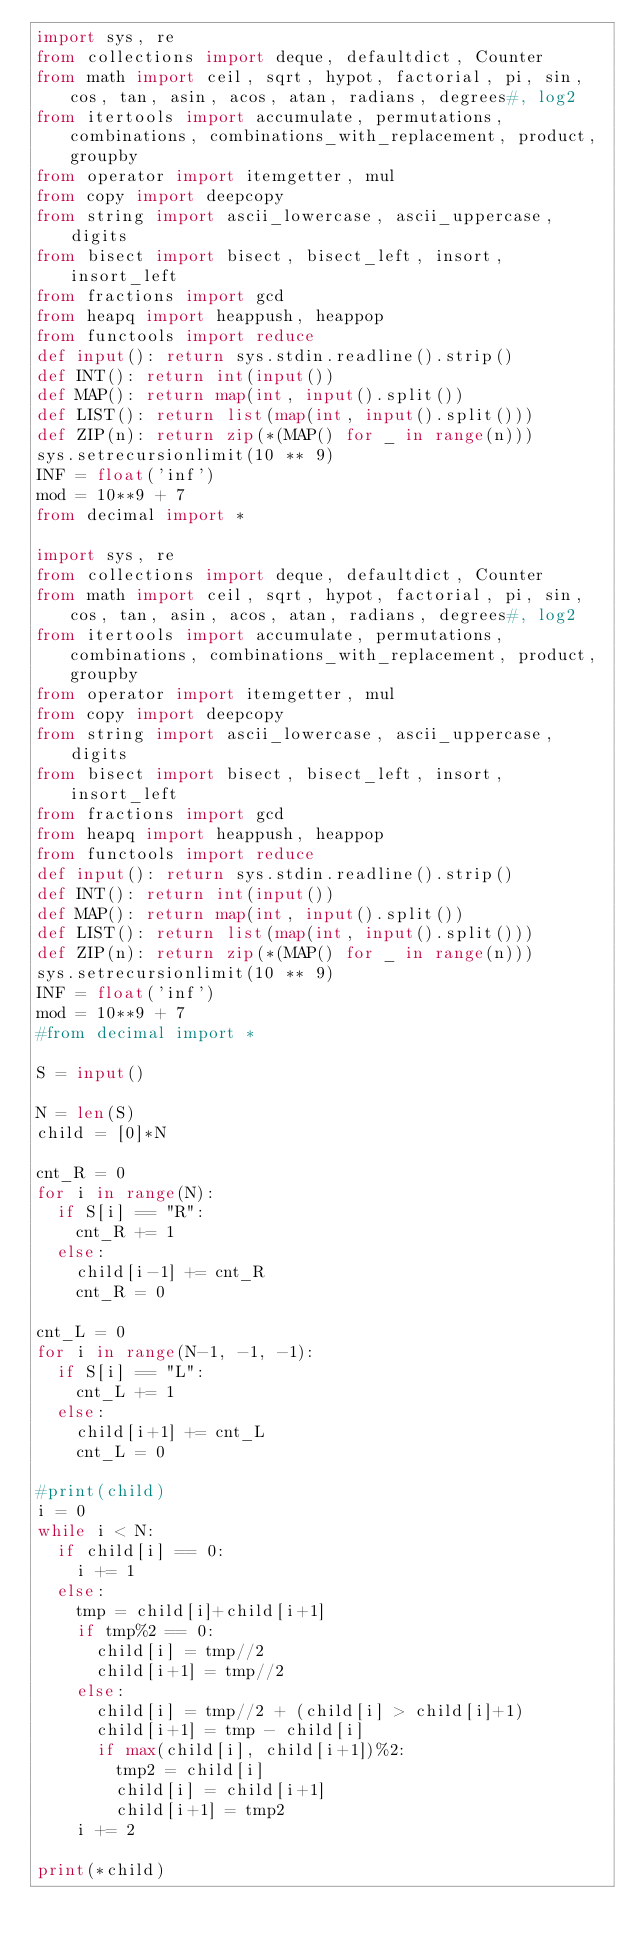<code> <loc_0><loc_0><loc_500><loc_500><_Python_>import sys, re
from collections import deque, defaultdict, Counter
from math import ceil, sqrt, hypot, factorial, pi, sin, cos, tan, asin, acos, atan, radians, degrees#, log2
from itertools import accumulate, permutations, combinations, combinations_with_replacement, product, groupby
from operator import itemgetter, mul
from copy import deepcopy
from string import ascii_lowercase, ascii_uppercase, digits
from bisect import bisect, bisect_left, insort, insort_left
from fractions import gcd
from heapq import heappush, heappop
from functools import reduce
def input(): return sys.stdin.readline().strip()
def INT(): return int(input())
def MAP(): return map(int, input().split())
def LIST(): return list(map(int, input().split()))
def ZIP(n): return zip(*(MAP() for _ in range(n)))
sys.setrecursionlimit(10 ** 9)
INF = float('inf')
mod = 10**9 + 7
from decimal import *

import sys, re
from collections import deque, defaultdict, Counter
from math import ceil, sqrt, hypot, factorial, pi, sin, cos, tan, asin, acos, atan, radians, degrees#, log2
from itertools import accumulate, permutations, combinations, combinations_with_replacement, product, groupby
from operator import itemgetter, mul
from copy import deepcopy
from string import ascii_lowercase, ascii_uppercase, digits
from bisect import bisect, bisect_left, insort, insort_left
from fractions import gcd
from heapq import heappush, heappop
from functools import reduce
def input(): return sys.stdin.readline().strip()
def INT(): return int(input())
def MAP(): return map(int, input().split())
def LIST(): return list(map(int, input().split()))
def ZIP(n): return zip(*(MAP() for _ in range(n)))
sys.setrecursionlimit(10 ** 9)
INF = float('inf')
mod = 10**9 + 7
#from decimal import *
 
S = input()
 
N = len(S)
child = [0]*N
 
cnt_R = 0
for i in range(N):
	if S[i] == "R":
		cnt_R += 1
	else:
		child[i-1] += cnt_R
		cnt_R = 0

cnt_L = 0
for i in range(N-1, -1, -1):
	if S[i] == "L":
		cnt_L += 1
	else:
		child[i+1] += cnt_L
		cnt_L = 0
 
#print(child)
i = 0
while i < N:
	if child[i] == 0:
		i += 1
	else:
		tmp = child[i]+child[i+1]
		if tmp%2 == 0:
			child[i] = tmp//2
			child[i+1] = tmp//2
		else:
			child[i] = tmp//2 + (child[i] > child[i]+1)
			child[i+1] = tmp - child[i]
			if max(child[i], child[i+1])%2:
				tmp2 = child[i]
				child[i] = child[i+1]
				child[i+1] = tmp2
		i += 2

print(*child)
</code> 